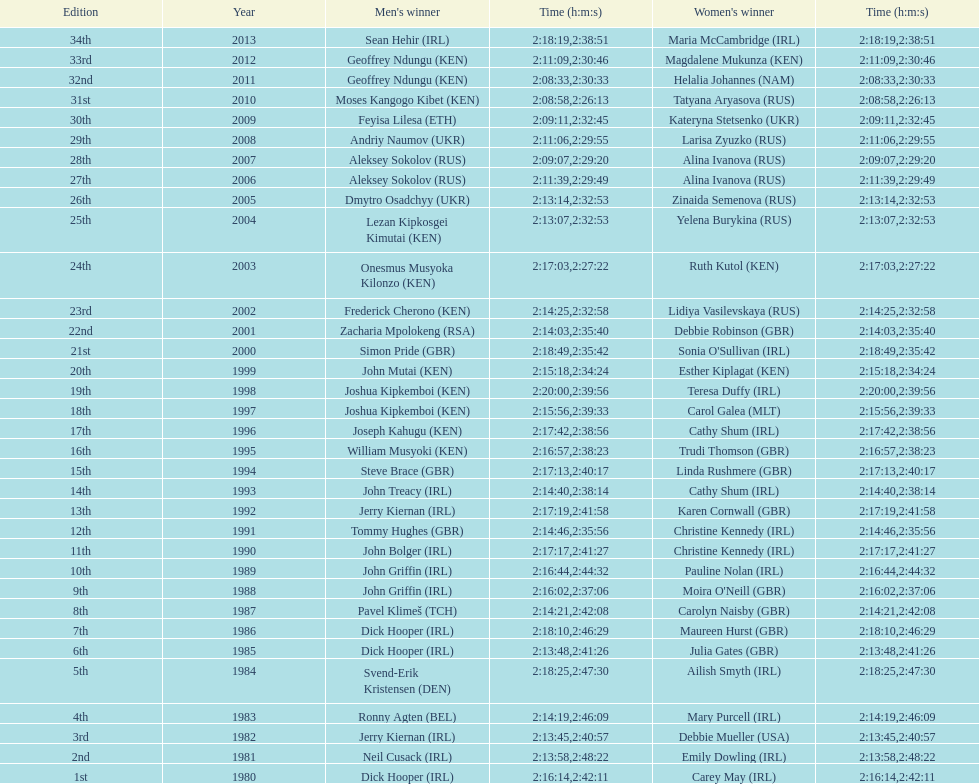In 2009, which competitor finished faster - the male or the female? Male. 